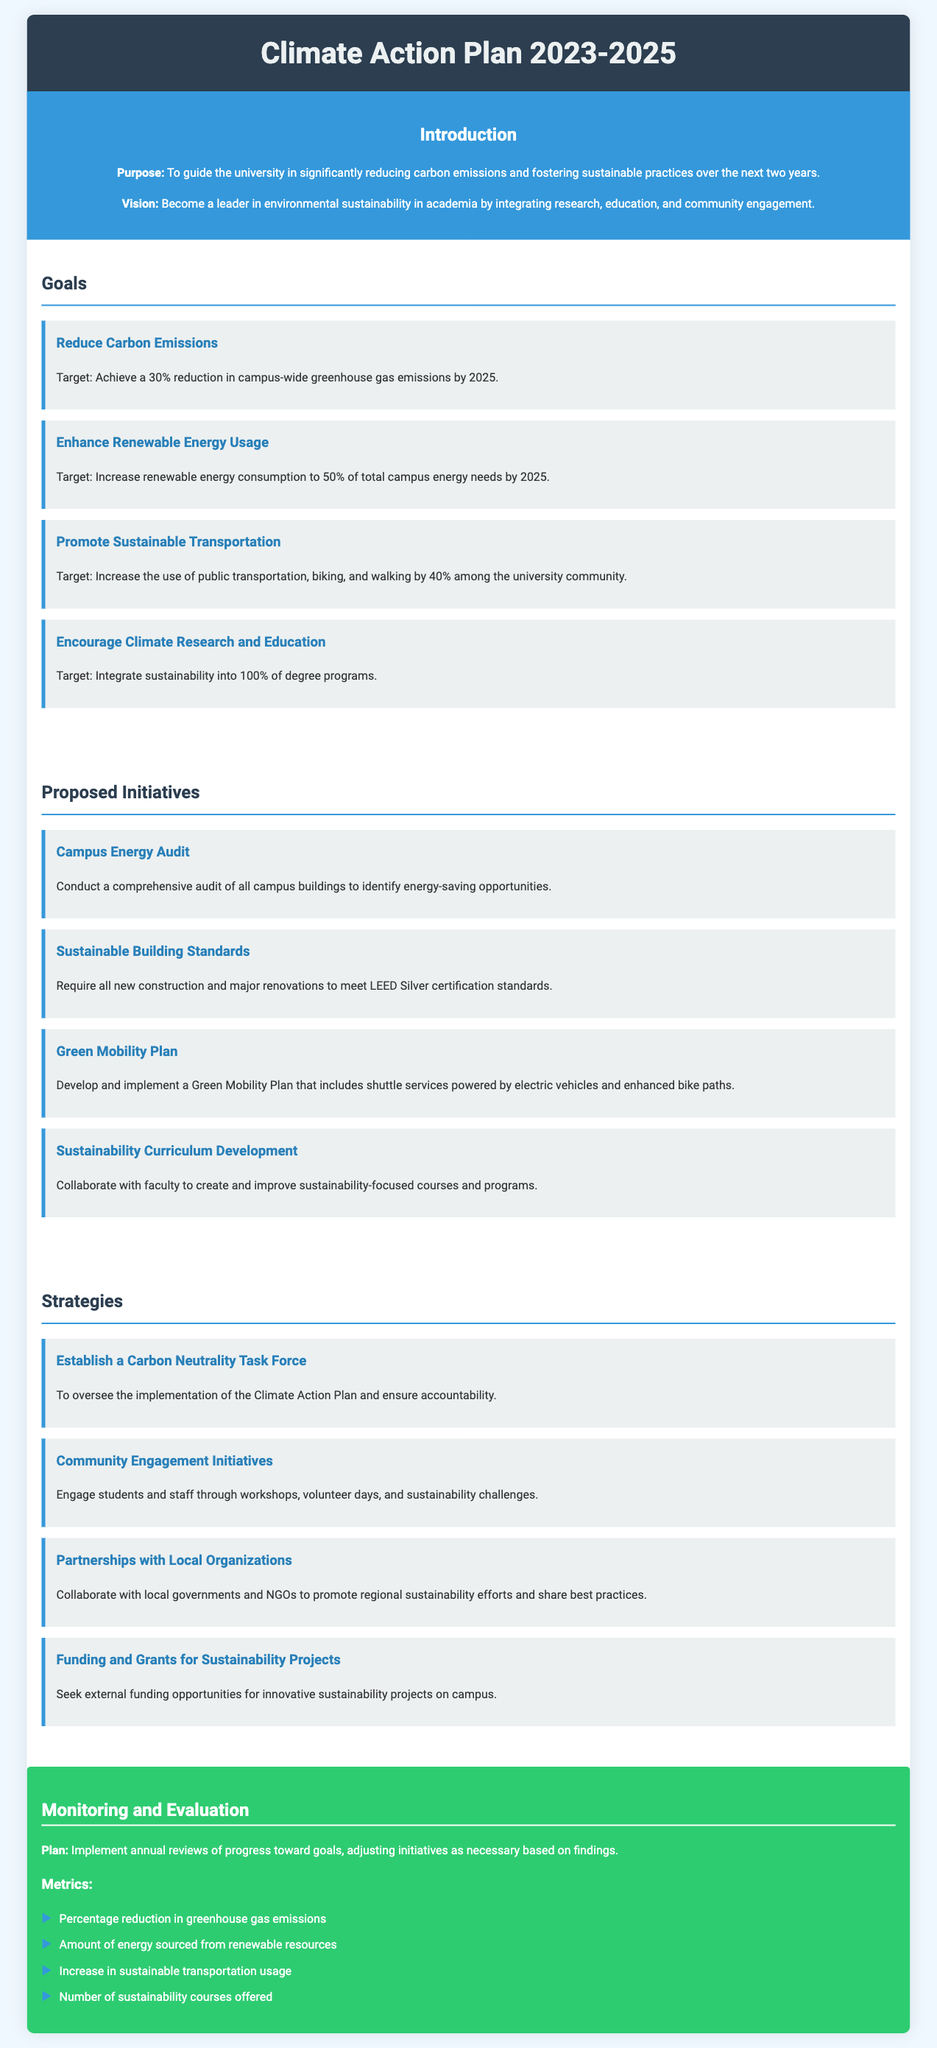What is the goal for carbon emissions reduction? The document states the target is to achieve a 30% reduction in campus-wide greenhouse gas emissions by 2025.
Answer: 30% What percentage of renewable energy consumption is targeted by 2025? The document indicates the target is to increase renewable energy consumption to 50% of total campus energy needs by 2025.
Answer: 50% Which initiative focuses on energy-saving opportunities? The comprehensive audit of all campus buildings is aimed at identifying energy-saving opportunities.
Answer: Campus Energy Audit What document type is this catalog? The document is a Climate Action Plan outlining proposed initiatives, goals, and strategies.
Answer: Climate Action Plan What is one of the strategies mentioned for community engagement? The document lists engaging students and staff through workshops, volunteer days, and sustainability challenges as one of the strategies.
Answer: Community Engagement Initiatives How many sustainability courses will be integrated into degree programs? The document specifies that sustainability will be integrated into 100% of degree programs.
Answer: 100% What are the metrics used for monitoring and evaluation? The document lists metrics such as percentage reduction in greenhouse gas emissions, amount of energy sourced from renewable resources, increase in sustainable transportation usage, and number of sustainability courses offered.
Answer: Percentage reduction in greenhouse gas emissions, amount of energy sourced from renewable resources, increase in sustainable transportation usage, number of sustainability courses offered Who will oversee the implementation of the Climate Action Plan? The document indicates that a Carbon Neutrality Task Force will oversee the implementation of the Climate Action Plan.
Answer: Carbon Neutrality Task Force What does the university aim to become in terms of environmental sustainability? The vision stated in the document is to become a leader in environmental sustainability in academia.
Answer: A leader in environmental sustainability 